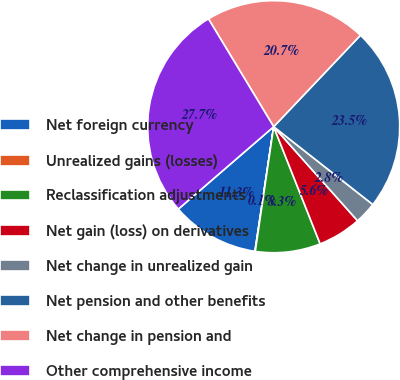Convert chart to OTSL. <chart><loc_0><loc_0><loc_500><loc_500><pie_chart><fcel>Net foreign currency<fcel>Unrealized gains (losses)<fcel>Reclassification adjustments<fcel>Net gain (loss) on derivatives<fcel>Net change in unrealized gain<fcel>Net pension and other benefits<fcel>Net change in pension and<fcel>Other comprehensive income<nl><fcel>11.28%<fcel>0.05%<fcel>8.34%<fcel>5.58%<fcel>2.82%<fcel>23.51%<fcel>20.74%<fcel>27.68%<nl></chart> 